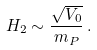Convert formula to latex. <formula><loc_0><loc_0><loc_500><loc_500>H _ { 2 } \sim \frac { \sqrt { V _ { 0 } } } { m _ { P } } \, .</formula> 